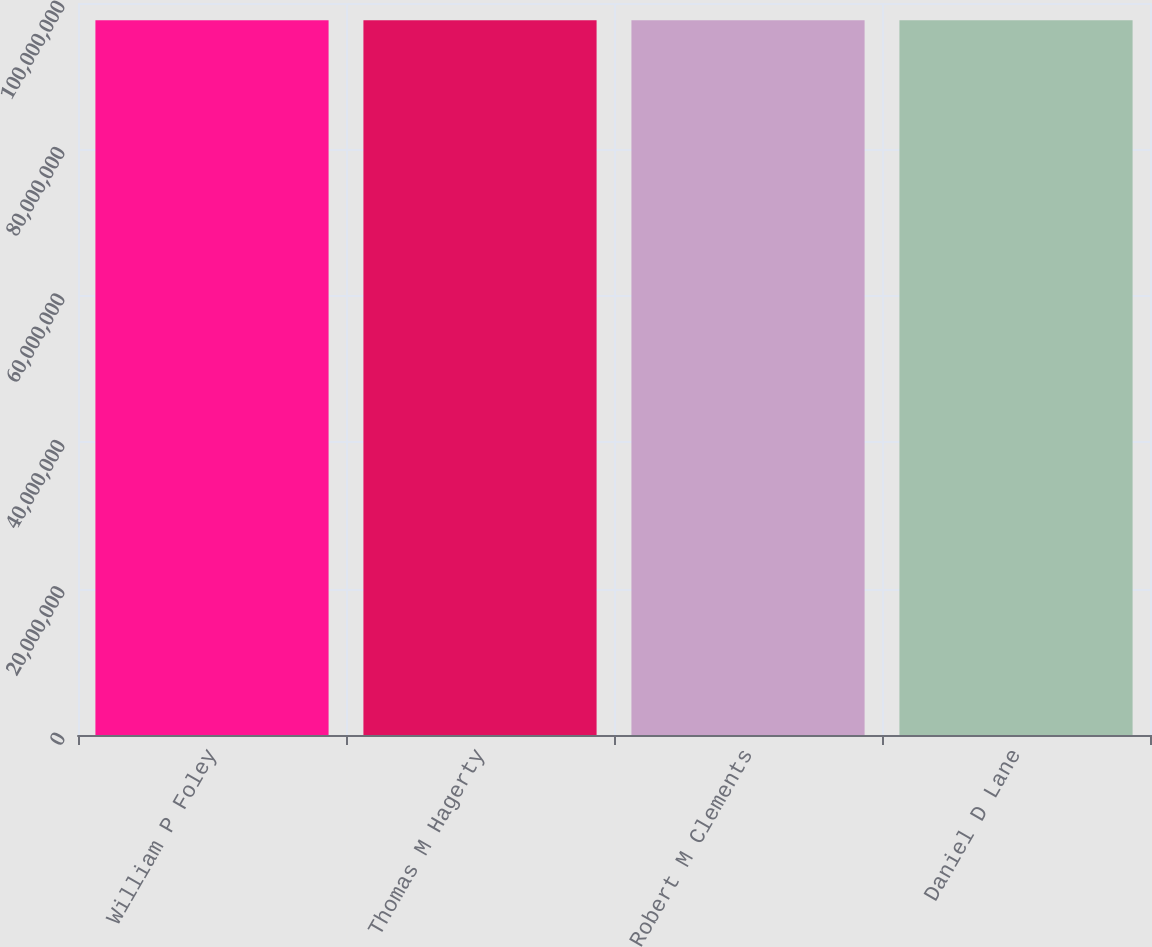Convert chart. <chart><loc_0><loc_0><loc_500><loc_500><bar_chart><fcel>William P Foley<fcel>Thomas M Hagerty<fcel>Robert M Clements<fcel>Daniel D Lane<nl><fcel>9.76465e+07<fcel>9.76465e+07<fcel>9.76465e+07<fcel>9.76465e+07<nl></chart> 